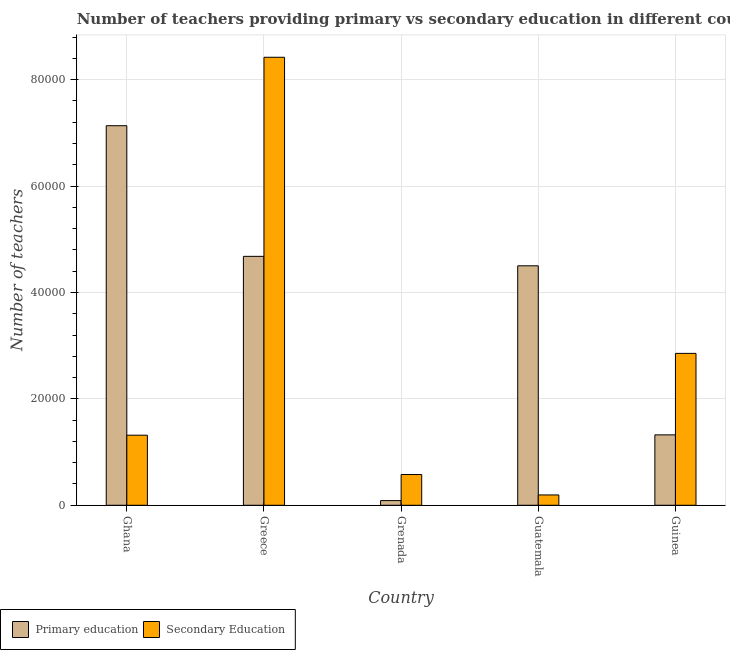How many different coloured bars are there?
Provide a short and direct response. 2. How many bars are there on the 5th tick from the left?
Ensure brevity in your answer.  2. What is the label of the 3rd group of bars from the left?
Your answer should be compact. Grenada. In how many cases, is the number of bars for a given country not equal to the number of legend labels?
Give a very brief answer. 0. What is the number of primary teachers in Ghana?
Your answer should be compact. 7.13e+04. Across all countries, what is the maximum number of secondary teachers?
Give a very brief answer. 8.42e+04. Across all countries, what is the minimum number of secondary teachers?
Make the answer very short. 1940. In which country was the number of secondary teachers maximum?
Offer a very short reply. Greece. In which country was the number of primary teachers minimum?
Ensure brevity in your answer.  Grenada. What is the total number of secondary teachers in the graph?
Make the answer very short. 1.34e+05. What is the difference between the number of secondary teachers in Greece and that in Guatemala?
Ensure brevity in your answer.  8.23e+04. What is the difference between the number of primary teachers in Grenada and the number of secondary teachers in Greece?
Offer a very short reply. -8.33e+04. What is the average number of primary teachers per country?
Keep it short and to the point. 3.54e+04. What is the difference between the number of primary teachers and number of secondary teachers in Guatemala?
Your answer should be compact. 4.31e+04. In how many countries, is the number of primary teachers greater than 76000 ?
Keep it short and to the point. 0. What is the ratio of the number of secondary teachers in Ghana to that in Guinea?
Keep it short and to the point. 0.46. What is the difference between the highest and the second highest number of primary teachers?
Your answer should be compact. 2.46e+04. What is the difference between the highest and the lowest number of primary teachers?
Offer a terse response. 7.05e+04. Is the sum of the number of primary teachers in Grenada and Guatemala greater than the maximum number of secondary teachers across all countries?
Make the answer very short. No. What does the 2nd bar from the left in Grenada represents?
Ensure brevity in your answer.  Secondary Education. What does the 1st bar from the right in Greece represents?
Your response must be concise. Secondary Education. How many bars are there?
Ensure brevity in your answer.  10. How many countries are there in the graph?
Give a very brief answer. 5. What is the difference between two consecutive major ticks on the Y-axis?
Ensure brevity in your answer.  2.00e+04. Does the graph contain any zero values?
Keep it short and to the point. No. Does the graph contain grids?
Provide a succinct answer. Yes. How many legend labels are there?
Your answer should be very brief. 2. How are the legend labels stacked?
Provide a succinct answer. Horizontal. What is the title of the graph?
Offer a very short reply. Number of teachers providing primary vs secondary education in different countries. What is the label or title of the X-axis?
Give a very brief answer. Country. What is the label or title of the Y-axis?
Give a very brief answer. Number of teachers. What is the Number of teachers of Primary education in Ghana?
Provide a succinct answer. 7.13e+04. What is the Number of teachers in Secondary Education in Ghana?
Keep it short and to the point. 1.32e+04. What is the Number of teachers of Primary education in Greece?
Make the answer very short. 4.68e+04. What is the Number of teachers in Secondary Education in Greece?
Your answer should be very brief. 8.42e+04. What is the Number of teachers in Primary education in Grenada?
Ensure brevity in your answer.  878. What is the Number of teachers in Secondary Education in Grenada?
Offer a very short reply. 5779. What is the Number of teachers of Primary education in Guatemala?
Keep it short and to the point. 4.50e+04. What is the Number of teachers of Secondary Education in Guatemala?
Your answer should be compact. 1940. What is the Number of teachers of Primary education in Guinea?
Keep it short and to the point. 1.32e+04. What is the Number of teachers in Secondary Education in Guinea?
Provide a succinct answer. 2.85e+04. Across all countries, what is the maximum Number of teachers of Primary education?
Ensure brevity in your answer.  7.13e+04. Across all countries, what is the maximum Number of teachers of Secondary Education?
Provide a short and direct response. 8.42e+04. Across all countries, what is the minimum Number of teachers of Primary education?
Provide a succinct answer. 878. Across all countries, what is the minimum Number of teachers of Secondary Education?
Your answer should be compact. 1940. What is the total Number of teachers in Primary education in the graph?
Make the answer very short. 1.77e+05. What is the total Number of teachers in Secondary Education in the graph?
Ensure brevity in your answer.  1.34e+05. What is the difference between the Number of teachers of Primary education in Ghana and that in Greece?
Give a very brief answer. 2.46e+04. What is the difference between the Number of teachers of Secondary Education in Ghana and that in Greece?
Your response must be concise. -7.10e+04. What is the difference between the Number of teachers of Primary education in Ghana and that in Grenada?
Your answer should be very brief. 7.05e+04. What is the difference between the Number of teachers of Secondary Education in Ghana and that in Grenada?
Offer a very short reply. 7392. What is the difference between the Number of teachers in Primary education in Ghana and that in Guatemala?
Your response must be concise. 2.63e+04. What is the difference between the Number of teachers in Secondary Education in Ghana and that in Guatemala?
Provide a succinct answer. 1.12e+04. What is the difference between the Number of teachers of Primary education in Ghana and that in Guinea?
Give a very brief answer. 5.81e+04. What is the difference between the Number of teachers of Secondary Education in Ghana and that in Guinea?
Your response must be concise. -1.54e+04. What is the difference between the Number of teachers in Primary education in Greece and that in Grenada?
Offer a very short reply. 4.59e+04. What is the difference between the Number of teachers of Secondary Education in Greece and that in Grenada?
Your response must be concise. 7.84e+04. What is the difference between the Number of teachers in Primary education in Greece and that in Guatemala?
Offer a very short reply. 1775. What is the difference between the Number of teachers in Secondary Education in Greece and that in Guatemala?
Offer a terse response. 8.23e+04. What is the difference between the Number of teachers of Primary education in Greece and that in Guinea?
Your response must be concise. 3.36e+04. What is the difference between the Number of teachers in Secondary Education in Greece and that in Guinea?
Your answer should be very brief. 5.57e+04. What is the difference between the Number of teachers of Primary education in Grenada and that in Guatemala?
Keep it short and to the point. -4.41e+04. What is the difference between the Number of teachers of Secondary Education in Grenada and that in Guatemala?
Your answer should be very brief. 3839. What is the difference between the Number of teachers of Primary education in Grenada and that in Guinea?
Offer a very short reply. -1.24e+04. What is the difference between the Number of teachers of Secondary Education in Grenada and that in Guinea?
Keep it short and to the point. -2.28e+04. What is the difference between the Number of teachers in Primary education in Guatemala and that in Guinea?
Give a very brief answer. 3.18e+04. What is the difference between the Number of teachers in Secondary Education in Guatemala and that in Guinea?
Keep it short and to the point. -2.66e+04. What is the difference between the Number of teachers of Primary education in Ghana and the Number of teachers of Secondary Education in Greece?
Offer a terse response. -1.29e+04. What is the difference between the Number of teachers in Primary education in Ghana and the Number of teachers in Secondary Education in Grenada?
Keep it short and to the point. 6.56e+04. What is the difference between the Number of teachers of Primary education in Ghana and the Number of teachers of Secondary Education in Guatemala?
Keep it short and to the point. 6.94e+04. What is the difference between the Number of teachers of Primary education in Ghana and the Number of teachers of Secondary Education in Guinea?
Offer a terse response. 4.28e+04. What is the difference between the Number of teachers in Primary education in Greece and the Number of teachers in Secondary Education in Grenada?
Keep it short and to the point. 4.10e+04. What is the difference between the Number of teachers in Primary education in Greece and the Number of teachers in Secondary Education in Guatemala?
Offer a terse response. 4.48e+04. What is the difference between the Number of teachers of Primary education in Greece and the Number of teachers of Secondary Education in Guinea?
Offer a very short reply. 1.82e+04. What is the difference between the Number of teachers in Primary education in Grenada and the Number of teachers in Secondary Education in Guatemala?
Offer a very short reply. -1062. What is the difference between the Number of teachers in Primary education in Grenada and the Number of teachers in Secondary Education in Guinea?
Ensure brevity in your answer.  -2.77e+04. What is the difference between the Number of teachers of Primary education in Guatemala and the Number of teachers of Secondary Education in Guinea?
Provide a succinct answer. 1.65e+04. What is the average Number of teachers in Primary education per country?
Provide a succinct answer. 3.54e+04. What is the average Number of teachers of Secondary Education per country?
Provide a succinct answer. 2.67e+04. What is the difference between the Number of teachers in Primary education and Number of teachers in Secondary Education in Ghana?
Provide a succinct answer. 5.82e+04. What is the difference between the Number of teachers of Primary education and Number of teachers of Secondary Education in Greece?
Make the answer very short. -3.74e+04. What is the difference between the Number of teachers of Primary education and Number of teachers of Secondary Education in Grenada?
Give a very brief answer. -4901. What is the difference between the Number of teachers of Primary education and Number of teachers of Secondary Education in Guatemala?
Your answer should be compact. 4.31e+04. What is the difference between the Number of teachers in Primary education and Number of teachers in Secondary Education in Guinea?
Keep it short and to the point. -1.53e+04. What is the ratio of the Number of teachers in Primary education in Ghana to that in Greece?
Give a very brief answer. 1.52. What is the ratio of the Number of teachers of Secondary Education in Ghana to that in Greece?
Offer a terse response. 0.16. What is the ratio of the Number of teachers of Primary education in Ghana to that in Grenada?
Your response must be concise. 81.25. What is the ratio of the Number of teachers of Secondary Education in Ghana to that in Grenada?
Ensure brevity in your answer.  2.28. What is the ratio of the Number of teachers of Primary education in Ghana to that in Guatemala?
Ensure brevity in your answer.  1.58. What is the ratio of the Number of teachers of Secondary Education in Ghana to that in Guatemala?
Provide a succinct answer. 6.79. What is the ratio of the Number of teachers in Primary education in Ghana to that in Guinea?
Keep it short and to the point. 5.39. What is the ratio of the Number of teachers of Secondary Education in Ghana to that in Guinea?
Offer a terse response. 0.46. What is the ratio of the Number of teachers of Primary education in Greece to that in Grenada?
Offer a very short reply. 53.29. What is the ratio of the Number of teachers of Secondary Education in Greece to that in Grenada?
Make the answer very short. 14.57. What is the ratio of the Number of teachers of Primary education in Greece to that in Guatemala?
Offer a terse response. 1.04. What is the ratio of the Number of teachers of Secondary Education in Greece to that in Guatemala?
Your answer should be very brief. 43.4. What is the ratio of the Number of teachers in Primary education in Greece to that in Guinea?
Make the answer very short. 3.54. What is the ratio of the Number of teachers in Secondary Education in Greece to that in Guinea?
Offer a terse response. 2.95. What is the ratio of the Number of teachers of Primary education in Grenada to that in Guatemala?
Ensure brevity in your answer.  0.02. What is the ratio of the Number of teachers in Secondary Education in Grenada to that in Guatemala?
Ensure brevity in your answer.  2.98. What is the ratio of the Number of teachers in Primary education in Grenada to that in Guinea?
Provide a succinct answer. 0.07. What is the ratio of the Number of teachers of Secondary Education in Grenada to that in Guinea?
Offer a terse response. 0.2. What is the ratio of the Number of teachers of Primary education in Guatemala to that in Guinea?
Offer a terse response. 3.4. What is the ratio of the Number of teachers in Secondary Education in Guatemala to that in Guinea?
Your response must be concise. 0.07. What is the difference between the highest and the second highest Number of teachers of Primary education?
Your answer should be compact. 2.46e+04. What is the difference between the highest and the second highest Number of teachers of Secondary Education?
Ensure brevity in your answer.  5.57e+04. What is the difference between the highest and the lowest Number of teachers in Primary education?
Provide a succinct answer. 7.05e+04. What is the difference between the highest and the lowest Number of teachers of Secondary Education?
Offer a very short reply. 8.23e+04. 